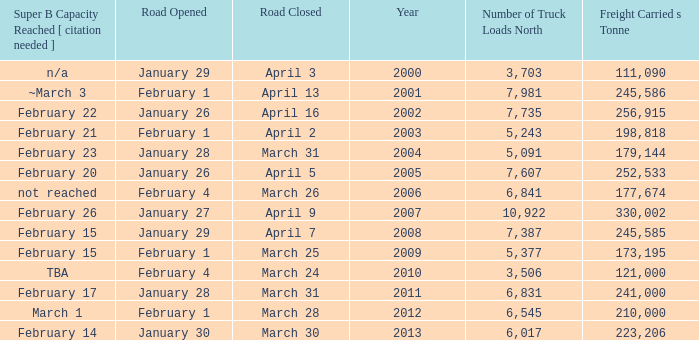What is the smallest amount of freight carried on the road that closed on March 31 and reached super B capacity on February 17 after 2011? None. Could you parse the entire table? {'header': ['Super B Capacity Reached [ citation needed ]', 'Road Opened', 'Road Closed', 'Year', 'Number of Truck Loads North', 'Freight Carried s Tonne'], 'rows': [['n/a', 'January 29', 'April 3', '2000', '3,703', '111,090'], ['~March 3', 'February 1', 'April 13', '2001', '7,981', '245,586'], ['February 22', 'January 26', 'April 16', '2002', '7,735', '256,915'], ['February 21', 'February 1', 'April 2', '2003', '5,243', '198,818'], ['February 23', 'January 28', 'March 31', '2004', '5,091', '179,144'], ['February 20', 'January 26', 'April 5', '2005', '7,607', '252,533'], ['not reached', 'February 4', 'March 26', '2006', '6,841', '177,674'], ['February 26', 'January 27', 'April 9', '2007', '10,922', '330,002'], ['February 15', 'January 29', 'April 7', '2008', '7,387', '245,585'], ['February 15', 'February 1', 'March 25', '2009', '5,377', '173,195'], ['TBA', 'February 4', 'March 24', '2010', '3,506', '121,000'], ['February 17', 'January 28', 'March 31', '2011', '6,831', '241,000'], ['March 1', 'February 1', 'March 28', '2012', '6,545', '210,000'], ['February 14', 'January 30', 'March 30', '2013', '6,017', '223,206']]} 